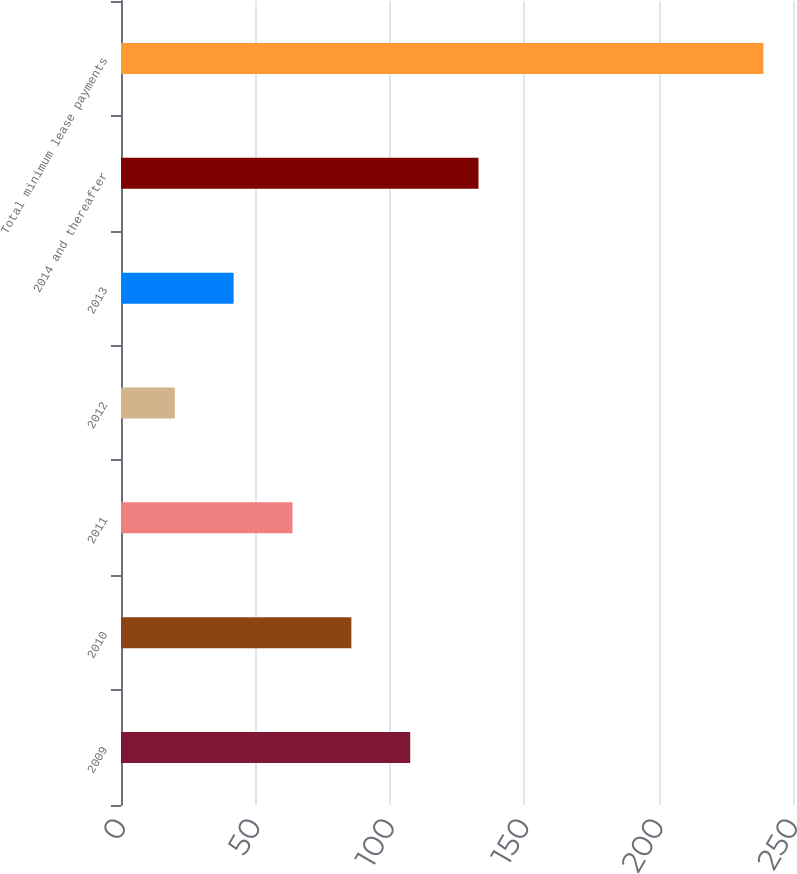Convert chart to OTSL. <chart><loc_0><loc_0><loc_500><loc_500><bar_chart><fcel>2009<fcel>2010<fcel>2011<fcel>2012<fcel>2013<fcel>2014 and thereafter<fcel>Total minimum lease payments<nl><fcel>107.6<fcel>85.7<fcel>63.8<fcel>20<fcel>41.9<fcel>133<fcel>239<nl></chart> 